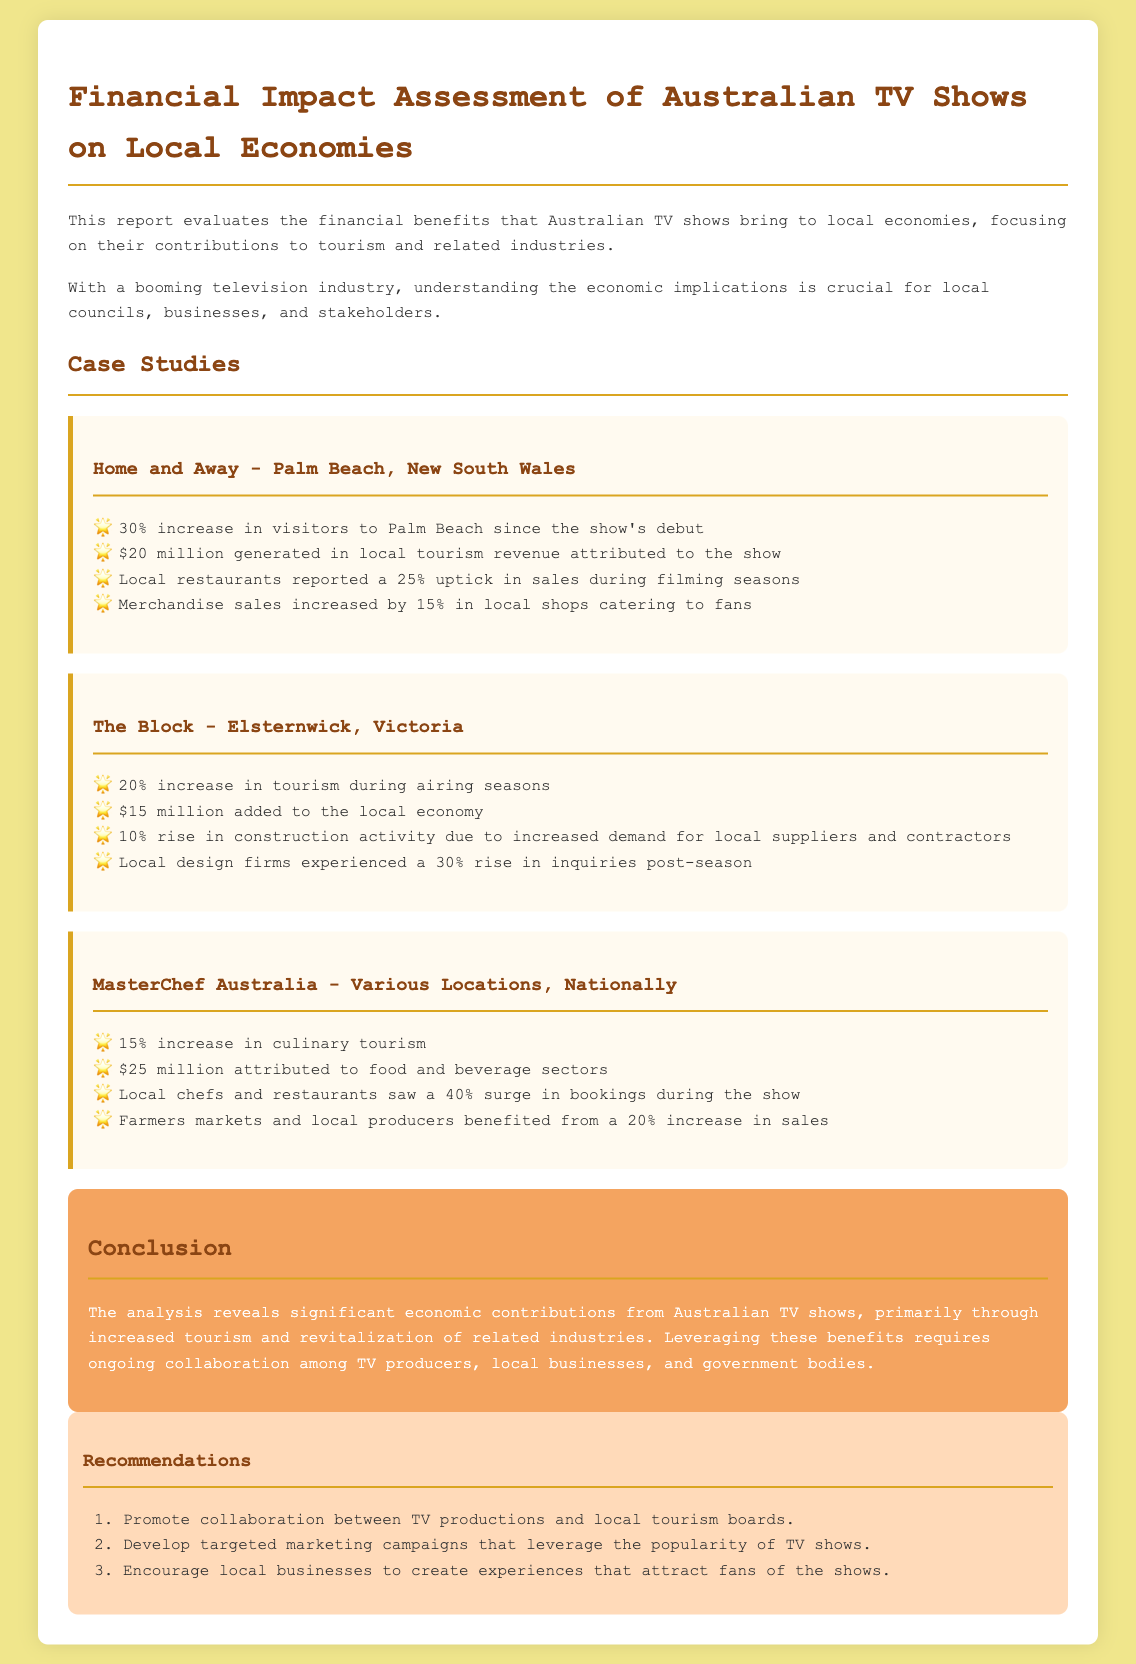What is the primary focus of the report? The report evaluates the financial benefits that Australian TV shows bring to local economies, focusing on their contributions to tourism and related industries.
Answer: Financial benefits from tourism and related industries How much revenue did "Home and Away" generate for local tourism? The document states that the show generated $20 million in local tourism revenue.
Answer: $20 million What percentage increase in visitors did "Home and Away" see? The report notes a 30% increase in visitors to Palm Beach since the show's debut.
Answer: 30% Which show contributed $25 million to food and beverage sectors? The document indicates that "MasterChef Australia" attributed $25 million to food and beverage sectors.
Answer: MasterChef Australia What is one recommendation made in the report? One recommendation is to promote collaboration between TV productions and local tourism boards.
Answer: Promote collaboration between TV productions and local tourism boards What was the increase in culinary tourism attributed to "MasterChef Australia"? The report indicates a 15% increase in culinary tourism attributed to the show.
Answer: 15% Which location benefited from a 20% increase in tourism during airing seasons? "The Block" is mentioned as having a 20% increase in tourism during airing seasons.
Answer: The Block What was the increase in local restaurant bookings during "MasterChef Australia"? The report states that local chefs and restaurants saw a 40% surge in bookings during the show.
Answer: 40% surge 